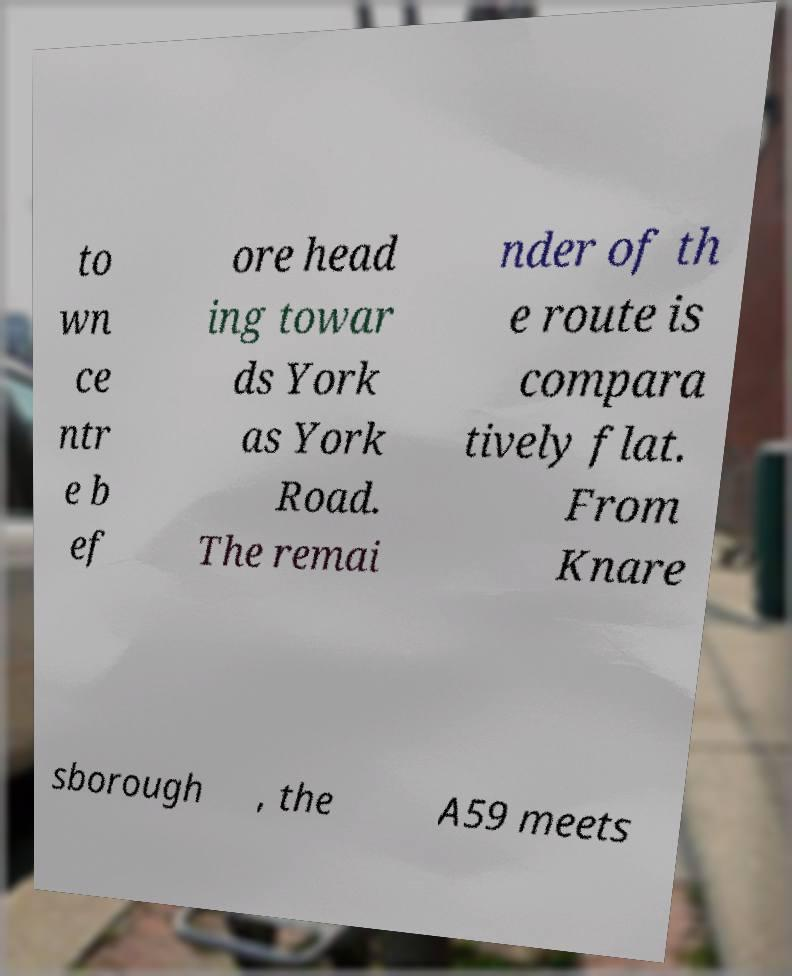There's text embedded in this image that I need extracted. Can you transcribe it verbatim? to wn ce ntr e b ef ore head ing towar ds York as York Road. The remai nder of th e route is compara tively flat. From Knare sborough , the A59 meets 